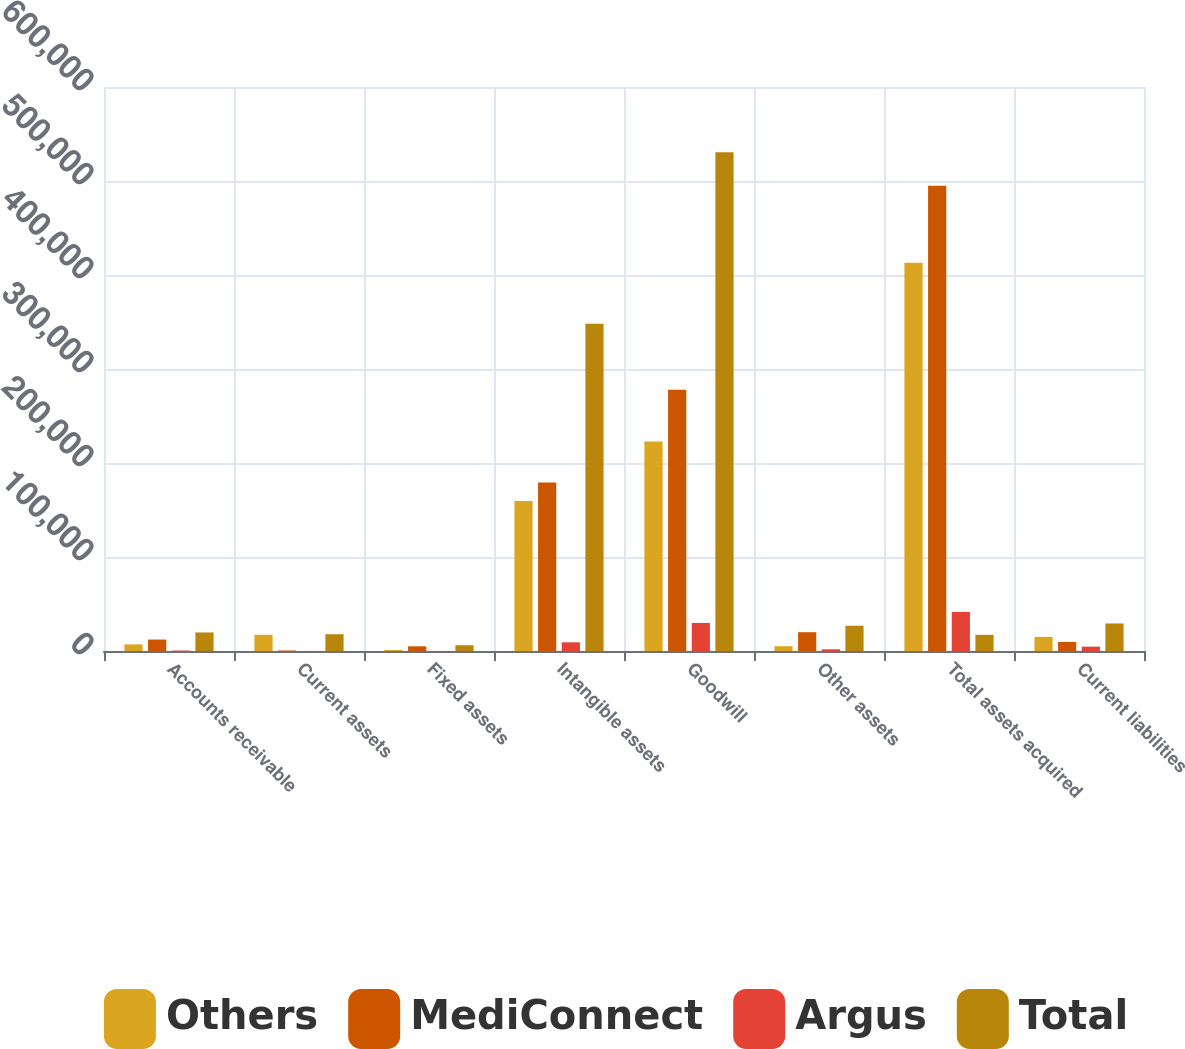Convert chart to OTSL. <chart><loc_0><loc_0><loc_500><loc_500><stacked_bar_chart><ecel><fcel>Accounts receivable<fcel>Current assets<fcel>Fixed assets<fcel>Intangible assets<fcel>Goodwill<fcel>Other assets<fcel>Total assets acquired<fcel>Current liabilities<nl><fcel>Others<fcel>7077<fcel>17238<fcel>1075<fcel>159506<fcel>222976<fcel>5087<fcel>412959<fcel>15007<nl><fcel>MediConnect<fcel>12165<fcel>568<fcel>4994<fcel>179316<fcel>277857<fcel>20000<fcel>494900<fcel>9661<nl><fcel>Argus<fcel>489<fcel>68<fcel>76<fcel>9264<fcel>29875<fcel>1801<fcel>41573<fcel>4625<nl><fcel>Total<fcel>19731<fcel>17874<fcel>6145<fcel>348086<fcel>530708<fcel>26888<fcel>17238<fcel>29293<nl></chart> 